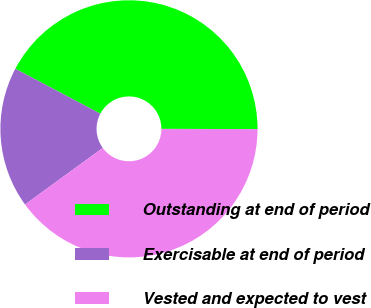Convert chart. <chart><loc_0><loc_0><loc_500><loc_500><pie_chart><fcel>Outstanding at end of period<fcel>Exercisable at end of period<fcel>Vested and expected to vest<nl><fcel>42.29%<fcel>17.76%<fcel>39.96%<nl></chart> 